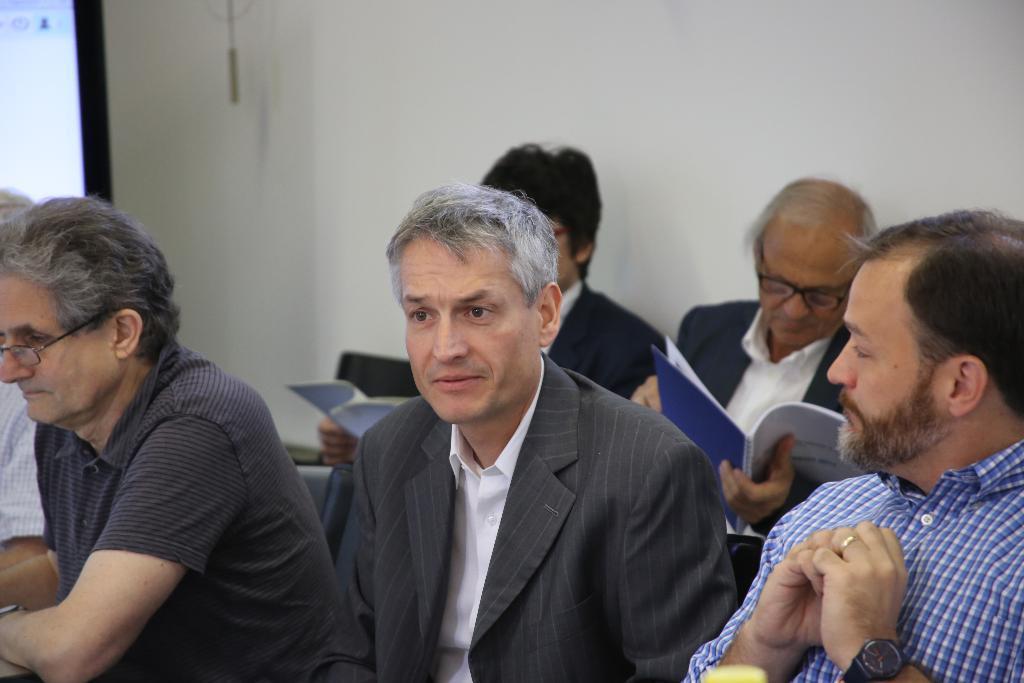Could you give a brief overview of what you see in this image? In the image we can see there are few men sitting, wearing clothes and some of them are wearing spectacles and wrist watch, two of them are holding books in their hands. Here we can see the wall and the background is slightly blurred. 